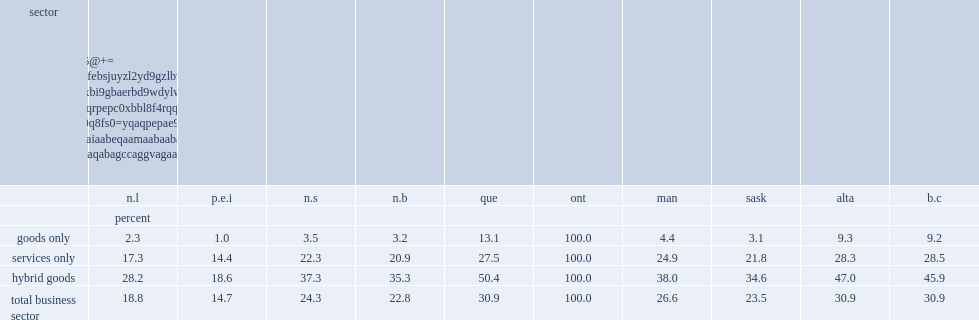What are the percentage of all operating locations in the business sector in ontario? 100.0. What are the percentage of operating locations in the business sector belong to firms in quebec? 30.9. What are the percentage belonging to firms in new brunswick? 22.8. What are the percentage belonging to firms in nova scotia? 24.3. What are the percentage belonging to firms in prince edward island? 14.7. What are the percentage belonging to firms in newfoundland and labrador? 18.8. What are the percentage of locations in ontario also being linked to alberta and british columbia?? 30.9. What are the percentage of operating locations in ontario belong to firms that also have operations in quebec? 13.1. 